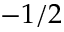<formula> <loc_0><loc_0><loc_500><loc_500>- 1 / 2</formula> 